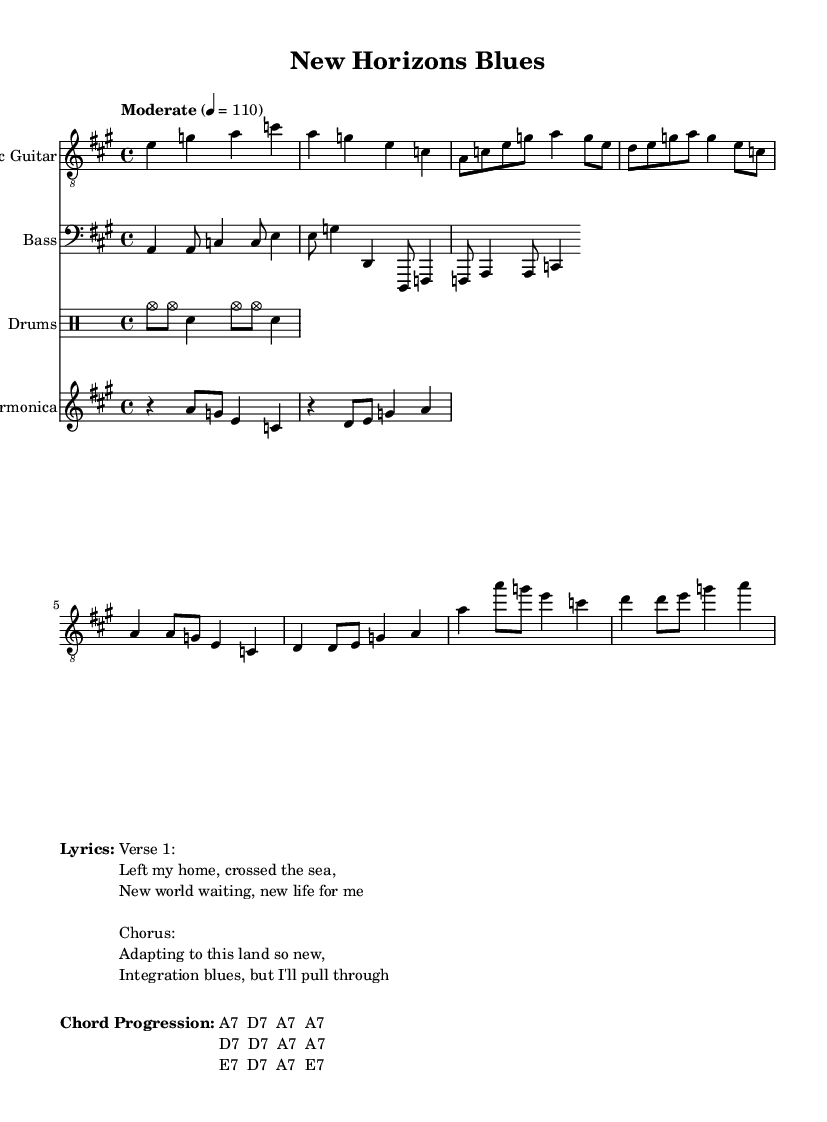What is the key signature of this music? The key signature is A major, which has three sharps: F#, C#, and G#. This can be identified at the beginning of the staff.
Answer: A major What is the time signature of this music? The time signature is 4/4, which can be found at the beginning of the score. This indicates that there are four beats in each measure.
Answer: 4/4 What is the tempo marking for this piece? The tempo marking is "Moderate" with a metronome marking of 4 = 110. This indicates a moderate pace at 110 beats per minute, which is noted directly in the score.
Answer: Moderate 4 = 110 How many measures are in the Intro section? The Intro consists of 2 measures, which can be counted by looking at the notated music and finding the first 2 complete measures of the introduction segment.
Answer: 2 measures What is the primary emotion conveyed in this Electric Blues piece? The primary emotion conveyed is one of struggle and resilience as it talks about adapting to a new country, reflecting the experiences of cultural integration. This is conveyed through the lyrics and the overall feel of the blues style.
Answer: Struggle and resilience Which instruments are used in this composition? The composition features Electric Guitar, Bass, Drums, and Harmonica, which can be identified by their respective staves labeled at the beginning of each section.
Answer: Electric Guitar, Bass, Drums, Harmonica What is the chord progression for the verse? The chord progression for the verse is A7, D7, A7, A7. This progression can be found in the chord notation provided below the lyrics section in the sheet music.
Answer: A7 D7 A7 A7 